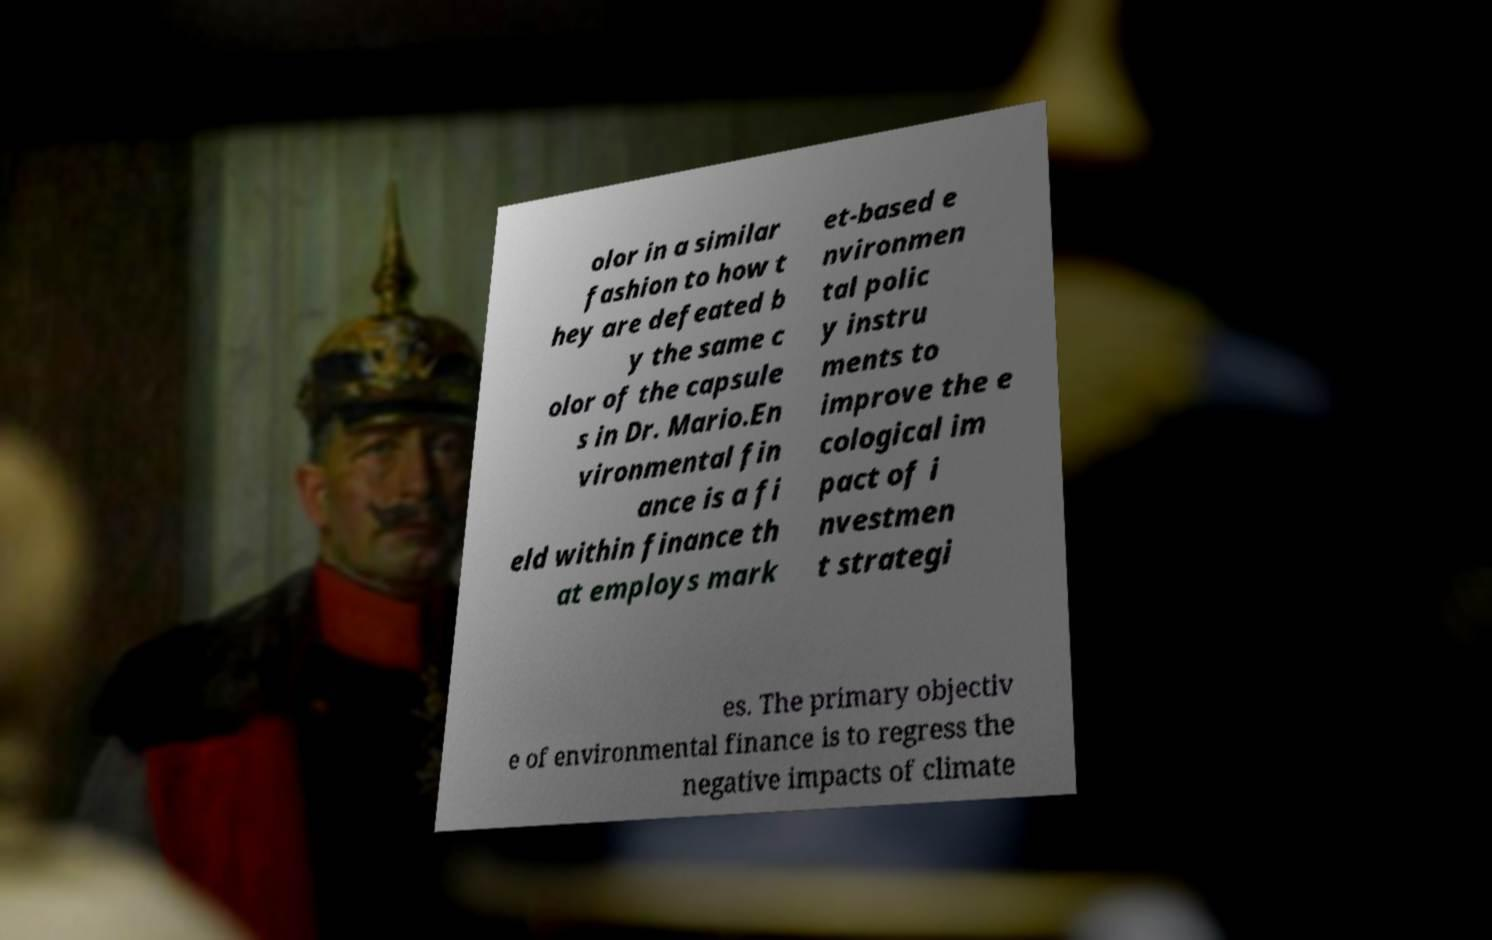What messages or text are displayed in this image? I need them in a readable, typed format. olor in a similar fashion to how t hey are defeated b y the same c olor of the capsule s in Dr. Mario.En vironmental fin ance is a fi eld within finance th at employs mark et-based e nvironmen tal polic y instru ments to improve the e cological im pact of i nvestmen t strategi es. The primary objectiv e of environmental finance is to regress the negative impacts of climate 